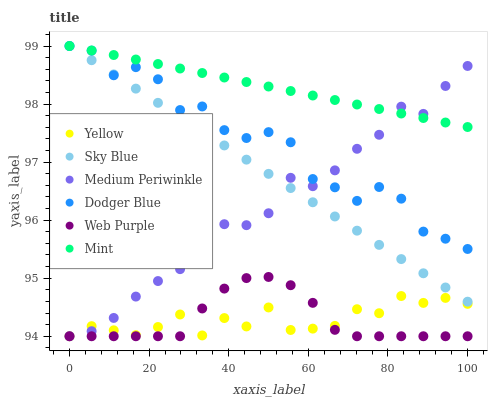Does Web Purple have the minimum area under the curve?
Answer yes or no. Yes. Does Mint have the maximum area under the curve?
Answer yes or no. Yes. Does Yellow have the minimum area under the curve?
Answer yes or no. No. Does Yellow have the maximum area under the curve?
Answer yes or no. No. Is Mint the smoothest?
Answer yes or no. Yes. Is Dodger Blue the roughest?
Answer yes or no. Yes. Is Yellow the smoothest?
Answer yes or no. No. Is Yellow the roughest?
Answer yes or no. No. Does Medium Periwinkle have the lowest value?
Answer yes or no. Yes. Does Dodger Blue have the lowest value?
Answer yes or no. No. Does Mint have the highest value?
Answer yes or no. Yes. Does Web Purple have the highest value?
Answer yes or no. No. Is Yellow less than Sky Blue?
Answer yes or no. Yes. Is Sky Blue greater than Web Purple?
Answer yes or no. Yes. Does Dodger Blue intersect Sky Blue?
Answer yes or no. Yes. Is Dodger Blue less than Sky Blue?
Answer yes or no. No. Is Dodger Blue greater than Sky Blue?
Answer yes or no. No. Does Yellow intersect Sky Blue?
Answer yes or no. No. 